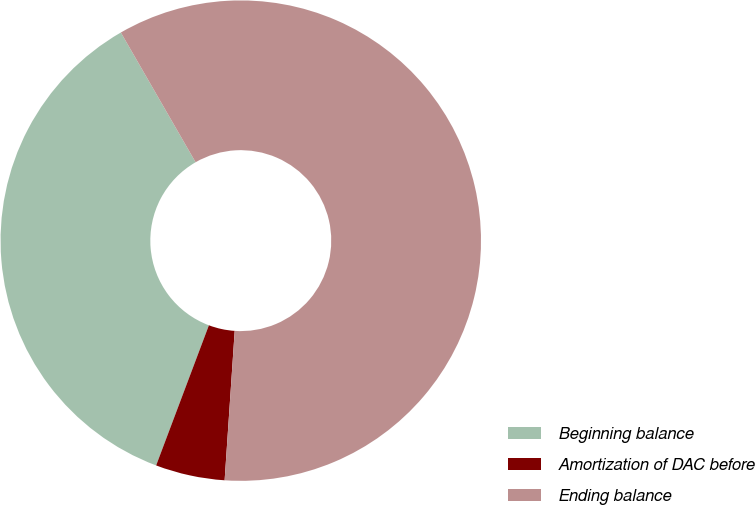Convert chart. <chart><loc_0><loc_0><loc_500><loc_500><pie_chart><fcel>Beginning balance<fcel>Amortization of DAC before<fcel>Ending balance<nl><fcel>35.95%<fcel>4.66%<fcel>59.39%<nl></chart> 